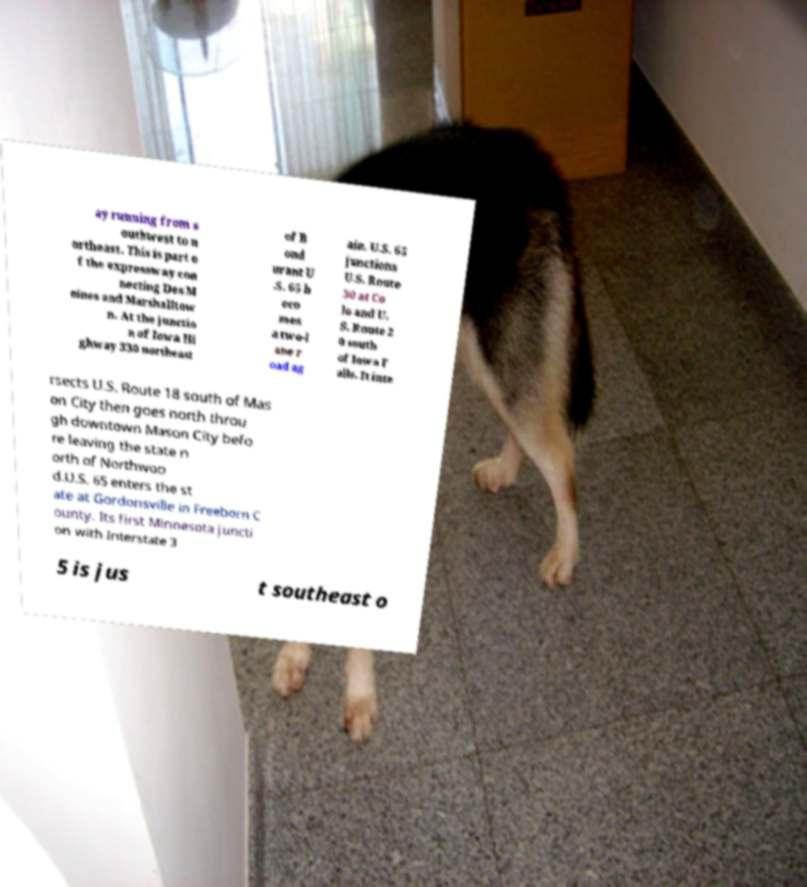For documentation purposes, I need the text within this image transcribed. Could you provide that? ay running from s outhwest to n ortheast. This is part o f the expressway con necting Des M oines and Marshalltow n. At the junctio n of Iowa Hi ghway 330 northeast of B ond urant U .S. 65 b eco mes a two-l ane r oad ag ain. U.S. 65 junctions U.S. Route 30 at Co lo and U. S. Route 2 0 south of Iowa F alls. It inte rsects U.S. Route 18 south of Mas on City then goes north throu gh downtown Mason City befo re leaving the state n orth of Northwoo d.U.S. 65 enters the st ate at Gordonsville in Freeborn C ounty. Its first Minnesota juncti on with Interstate 3 5 is jus t southeast o 